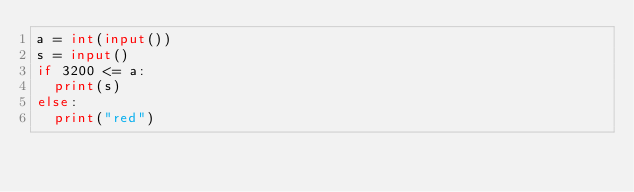Convert code to text. <code><loc_0><loc_0><loc_500><loc_500><_Python_>a = int(input())
s = input()
if 3200 <= a:
  print(s)
else:
  print("red")</code> 